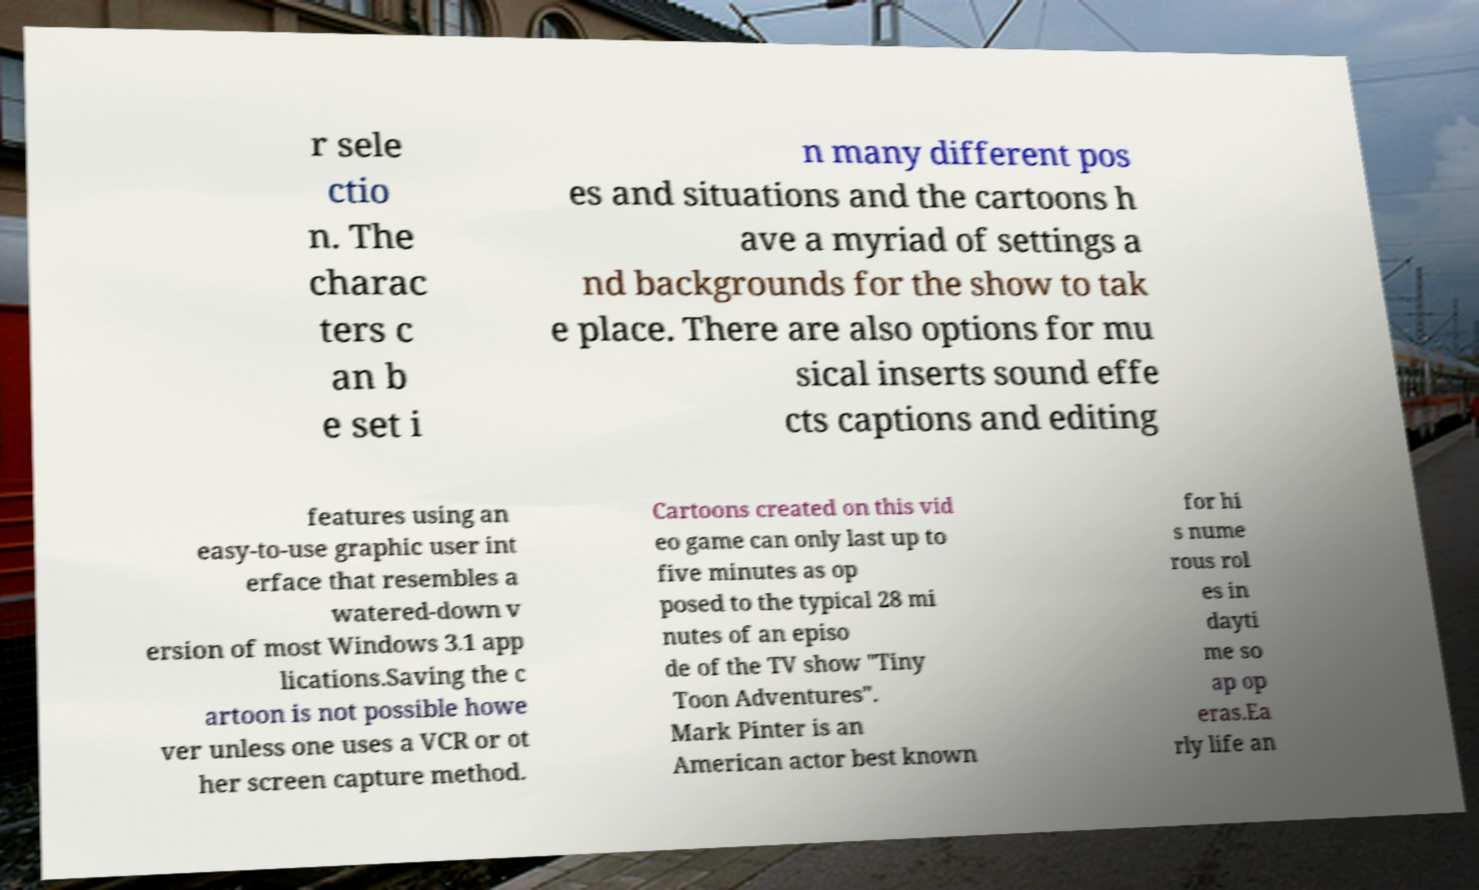Could you assist in decoding the text presented in this image and type it out clearly? r sele ctio n. The charac ters c an b e set i n many different pos es and situations and the cartoons h ave a myriad of settings a nd backgrounds for the show to tak e place. There are also options for mu sical inserts sound effe cts captions and editing features using an easy-to-use graphic user int erface that resembles a watered-down v ersion of most Windows 3.1 app lications.Saving the c artoon is not possible howe ver unless one uses a VCR or ot her screen capture method. Cartoons created on this vid eo game can only last up to five minutes as op posed to the typical 28 mi nutes of an episo de of the TV show "Tiny Toon Adventures". Mark Pinter is an American actor best known for hi s nume rous rol es in dayti me so ap op eras.Ea rly life an 